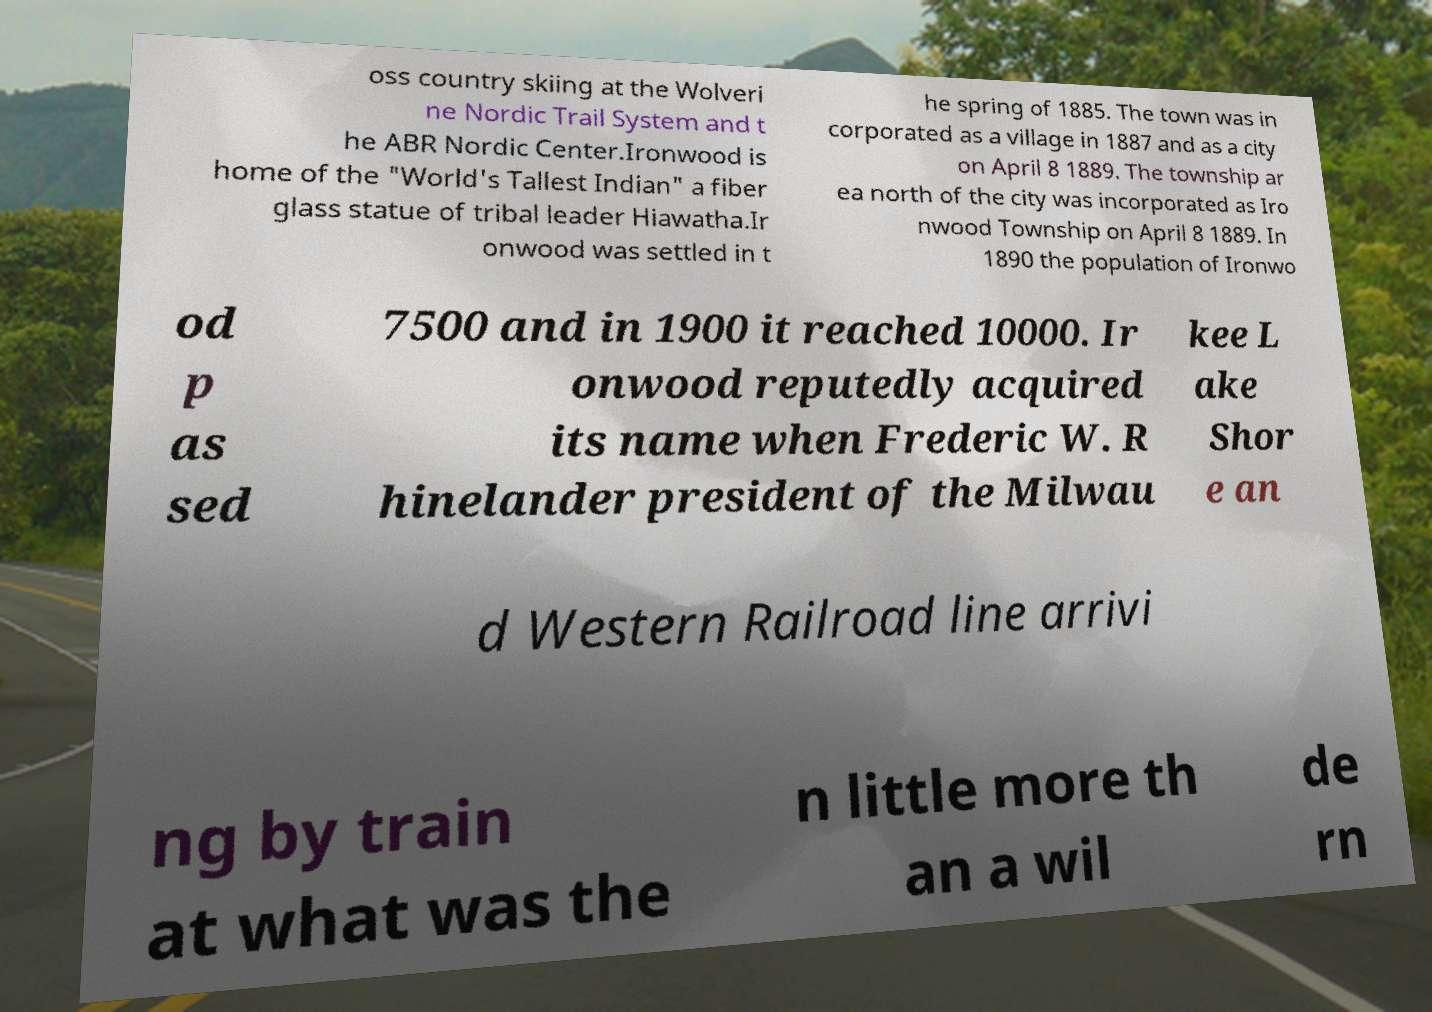Can you read and provide the text displayed in the image?This photo seems to have some interesting text. Can you extract and type it out for me? oss country skiing at the Wolveri ne Nordic Trail System and t he ABR Nordic Center.Ironwood is home of the "World's Tallest Indian" a fiber glass statue of tribal leader Hiawatha.Ir onwood was settled in t he spring of 1885. The town was in corporated as a village in 1887 and as a city on April 8 1889. The township ar ea north of the city was incorporated as Iro nwood Township on April 8 1889. In 1890 the population of Ironwo od p as sed 7500 and in 1900 it reached 10000. Ir onwood reputedly acquired its name when Frederic W. R hinelander president of the Milwau kee L ake Shor e an d Western Railroad line arrivi ng by train at what was the n little more th an a wil de rn 